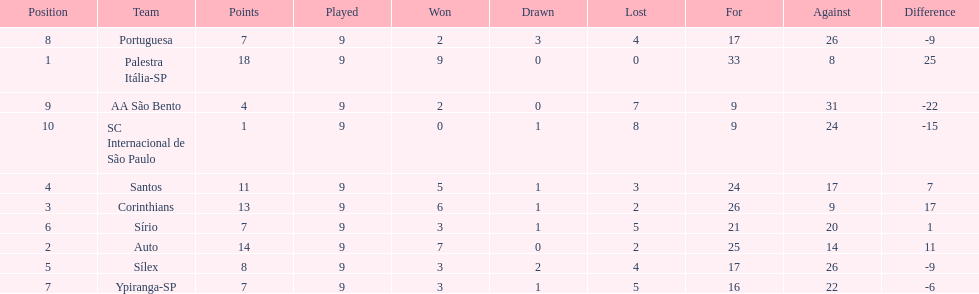How many teams had more points than silex? 4. 